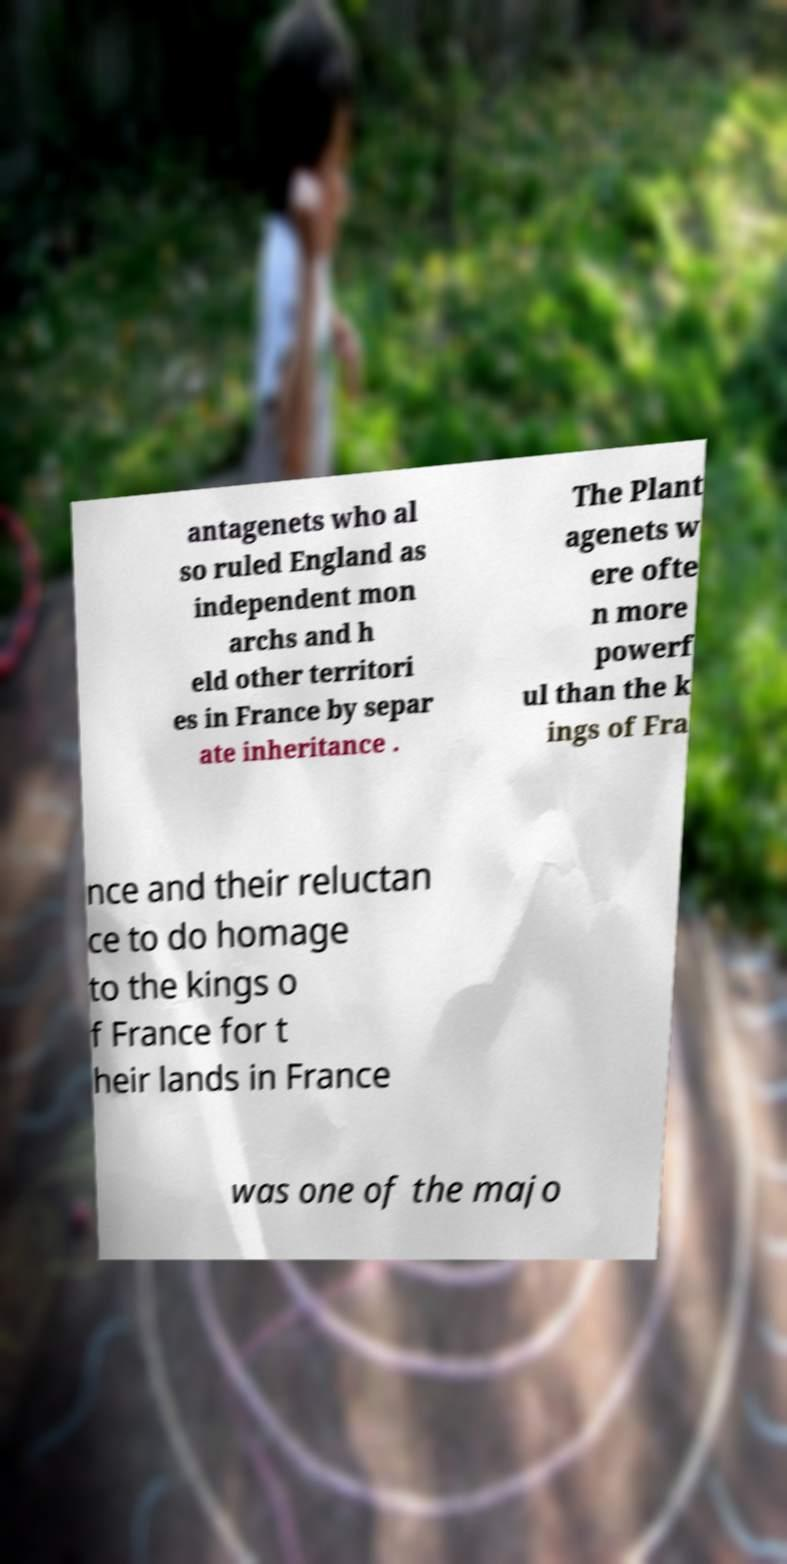Please identify and transcribe the text found in this image. antagenets who al so ruled England as independent mon archs and h eld other territori es in France by separ ate inheritance . The Plant agenets w ere ofte n more powerf ul than the k ings of Fra nce and their reluctan ce to do homage to the kings o f France for t heir lands in France was one of the majo 